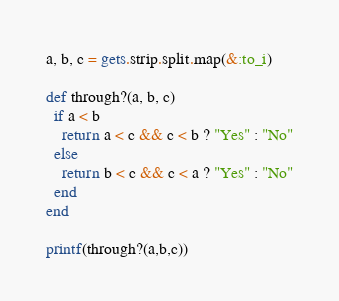<code> <loc_0><loc_0><loc_500><loc_500><_Ruby_>a, b, c = gets.strip.split.map(&:to_i)

def through?(a, b, c)
  if a < b
    return a < c && c < b ? "Yes" : "No"
  else
    return b < c && c < a ? "Yes" : "No"
  end
end

printf(through?(a,b,c))</code> 